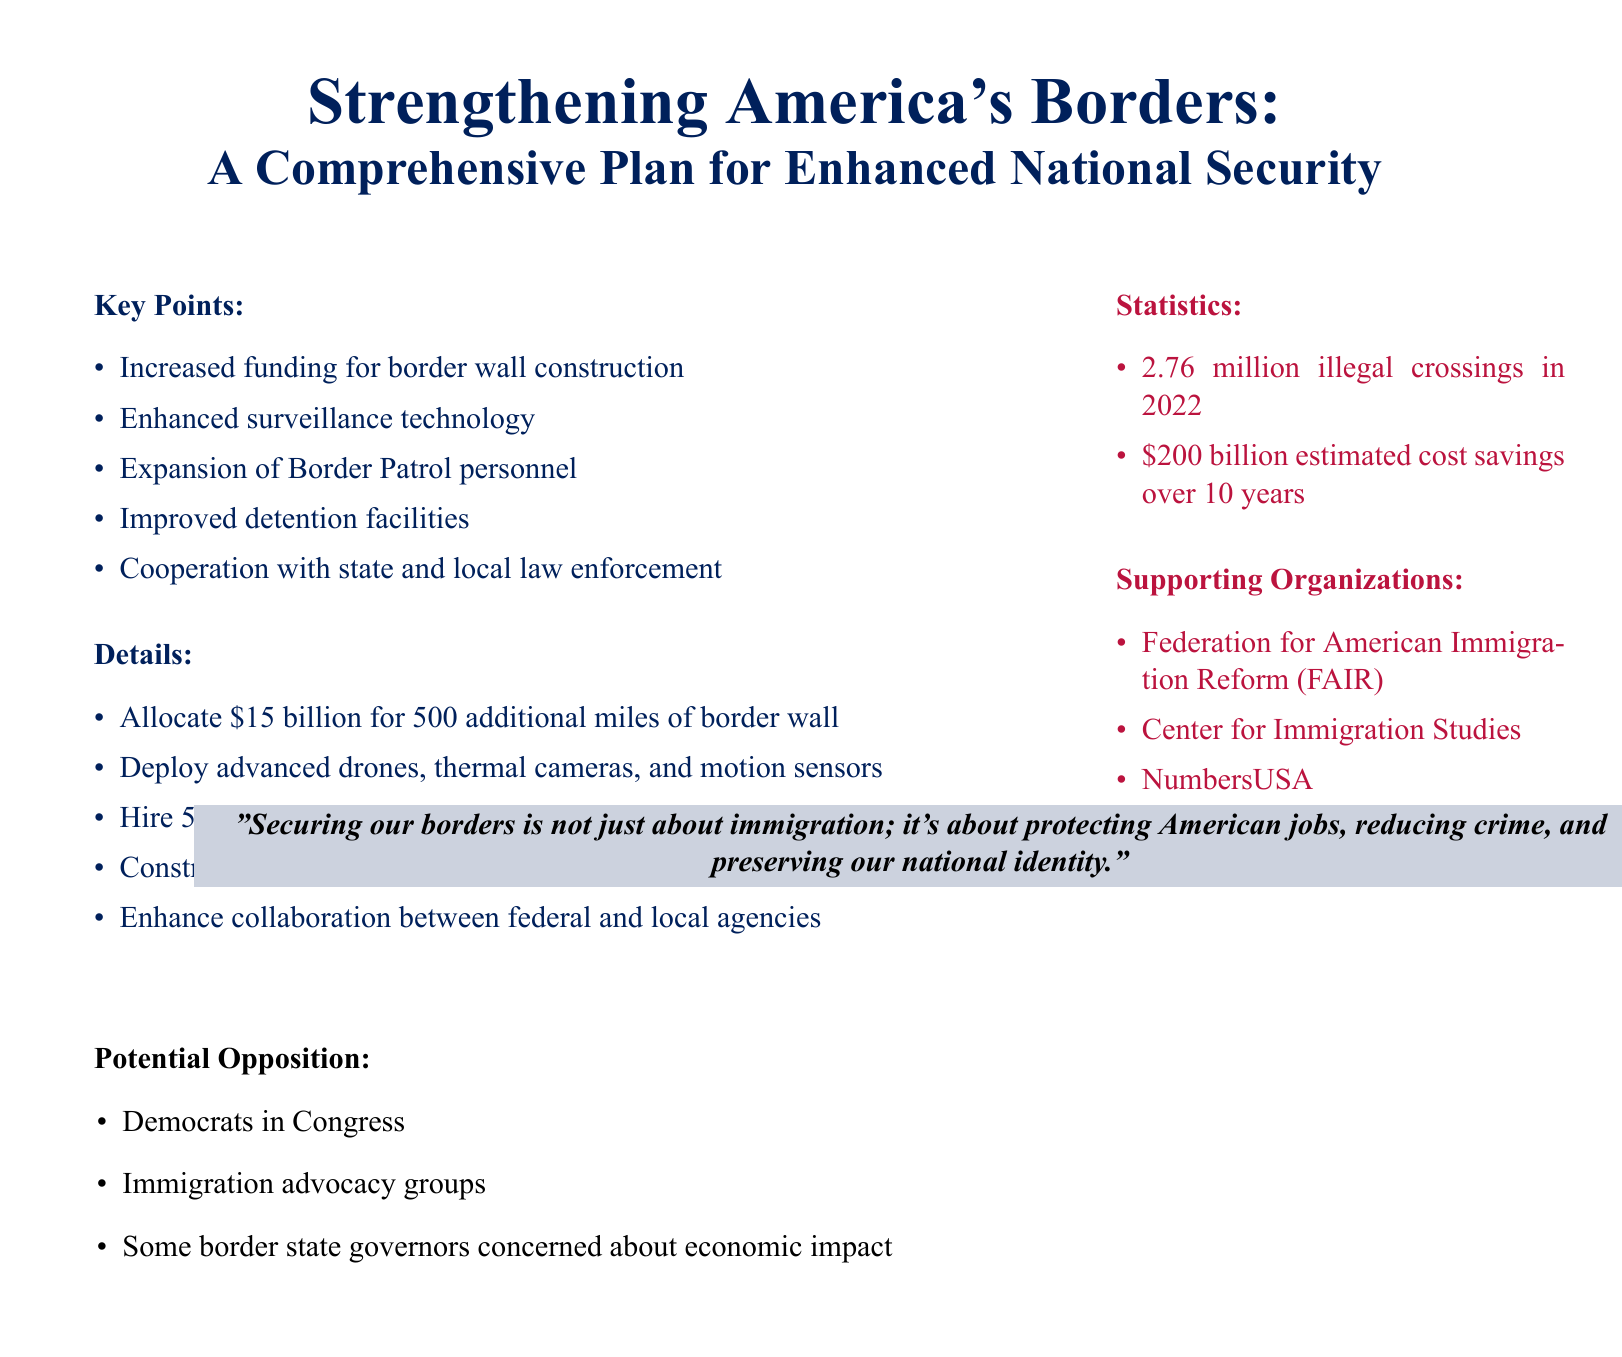What is the proposed funding amount for the border wall? The document specifies allocating $15 billion for border wall construction.
Answer: $15 billion How many additional Border Patrol agents are planned to be hired? The plan includes hiring 5,000 additional Border Patrol agents.
Answer: 5,000 What is the estimated number of illegal crossings in 2022? The document states there were 2.76 million illegal crossings in 2022.
Answer: 2.76 million Which organizations support the proposal? The document lists multiple supporting organizations including the Federation for American Immigration Reform (FAIR) and the Center for Immigration Studies.
Answer: Federation for American Immigration Reform (FAIR) What technology will be deployed for border surveillance? The proposal outlines deploying advanced drones, thermal cameras, and motion sensors.
Answer: Drones, thermal cameras, motion sensors What is the anticipated cost savings over ten years? The document mentions an estimated cost savings of $200 billion over 10 years.
Answer: $200 billion Who are identified as potential opposition to the proposal? The document mentions Democrats in Congress and immigration advocacy groups as potential opposition.
Answer: Democrats in Congress What is the primary goal of the proposed border control measures? The overall aim is to enhance national security through stricter border control.
Answer: National security How many miles of border wall construction is planned? The proposal mentions constructing 500 additional miles of border wall.
Answer: 500 miles 